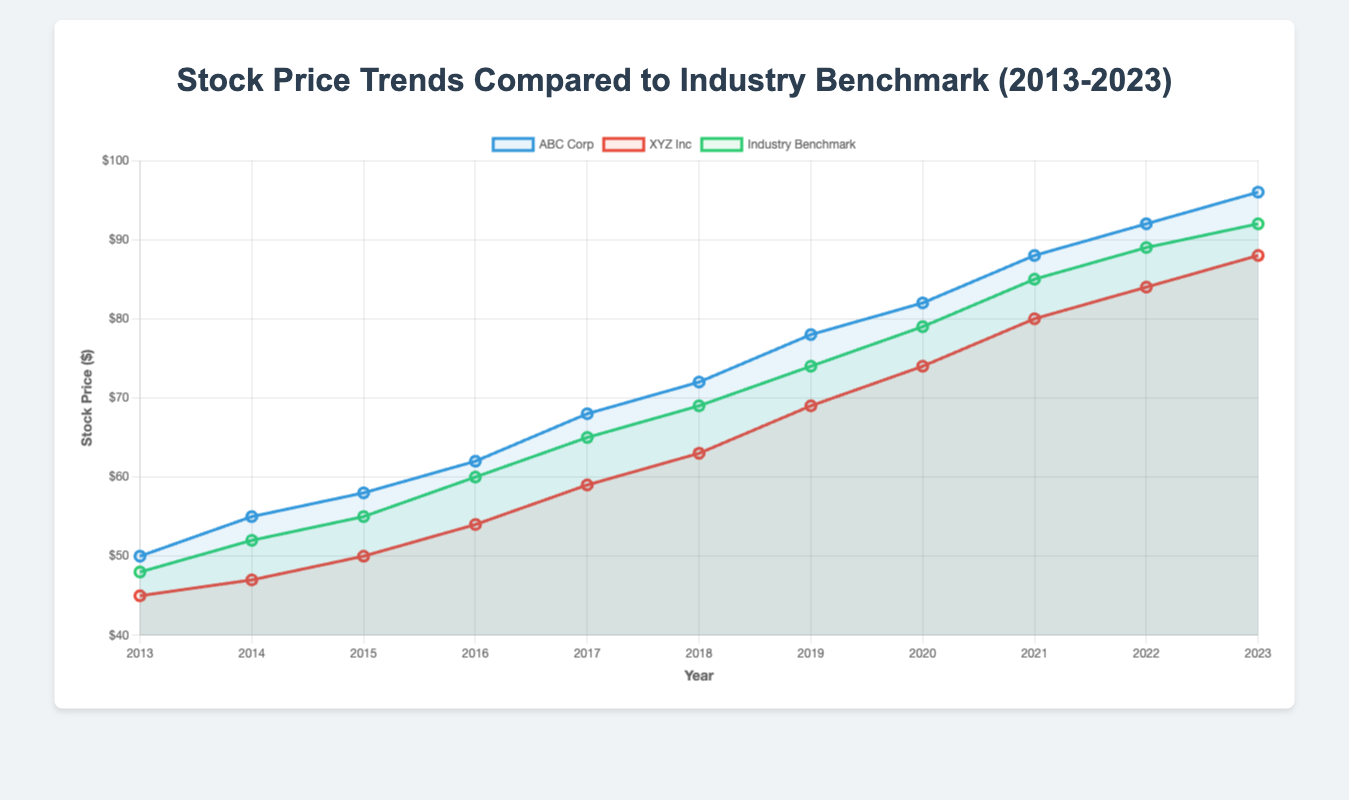What is the overall trend of ABC Corp's stock price from 2013 to 2023? From the figure, ABC Corp's stock price generally shows an upward trend. The stock price starts at $50 in 2013 and increases steadily to $96 by 2023.
Answer: Upward trend How did XYZ Inc's stock price in 2020 compare to the Industry Benchmark? In the figure, XYZ Inc's stock price in 2020 is $74, while the Industry Benchmark is $79. Thus, XYZ Inc's stock price is $5 less than the Industry Benchmark.
Answer: $5 less Which company's stock price exceeded the Industry Benchmark more frequently from 2013 to 2023? By visually comparing the lines, ABC Corp’s stock price often stays above the Industry Benchmark, whereas XYZ Inc's stock price remains below the Industry Benchmark for all the years. Hence, ABC Corp's stock price exceeded the Industry Benchmark more frequently.
Answer: ABC Corp During which years did ABC Corp's stock price increase by more than $6 compared to the previous year? By examining the differences in ABC Corp's stock prices year over year, the increases greater than $6 occur between 2016 and 2017 ($6), between 2017 and 2018 ($4), and between 2020 to 2021 ($6). So, 2016-2017 and 2020-2021.
Answer: 2016-2017, 2020-2021 What was the visual gap between ABC Corp's and XYZ Inc's stock prices in 2023? In 2023, ABC Corp's stock price is $96 and XYZ Inc's stock price is $88. Visually, the gap between them is represented by $8 on the y-axis.
Answer: $8 In which year did XYZ Inc experience its highest stock price? By looking at the dataset in conjunction with the figure, XYZ Inc's highest stock price appears in 2023, with a value of $88.
Answer: 2023 Which year showed the highest stock price for both ABC Corp and the Industry Benchmark? According to the figure, 2023 shows the highest stock price for both ABC Corp ($96) and the Industry Benchmark ($92).
Answer: 2023 How does the visual representation of the stock price trend of XYZ Inc from 2013 to 2023 differ from that of ABC Corp? The figure shows XYZ Inc's stock price increasing steadily but consistently below the industry benchmark, while ABC Corp's stock price similarly increases but generally stays above the industry benchmark.
Answer: Below benchmark for XYZ Inc, above benchmark for ABC Corp 